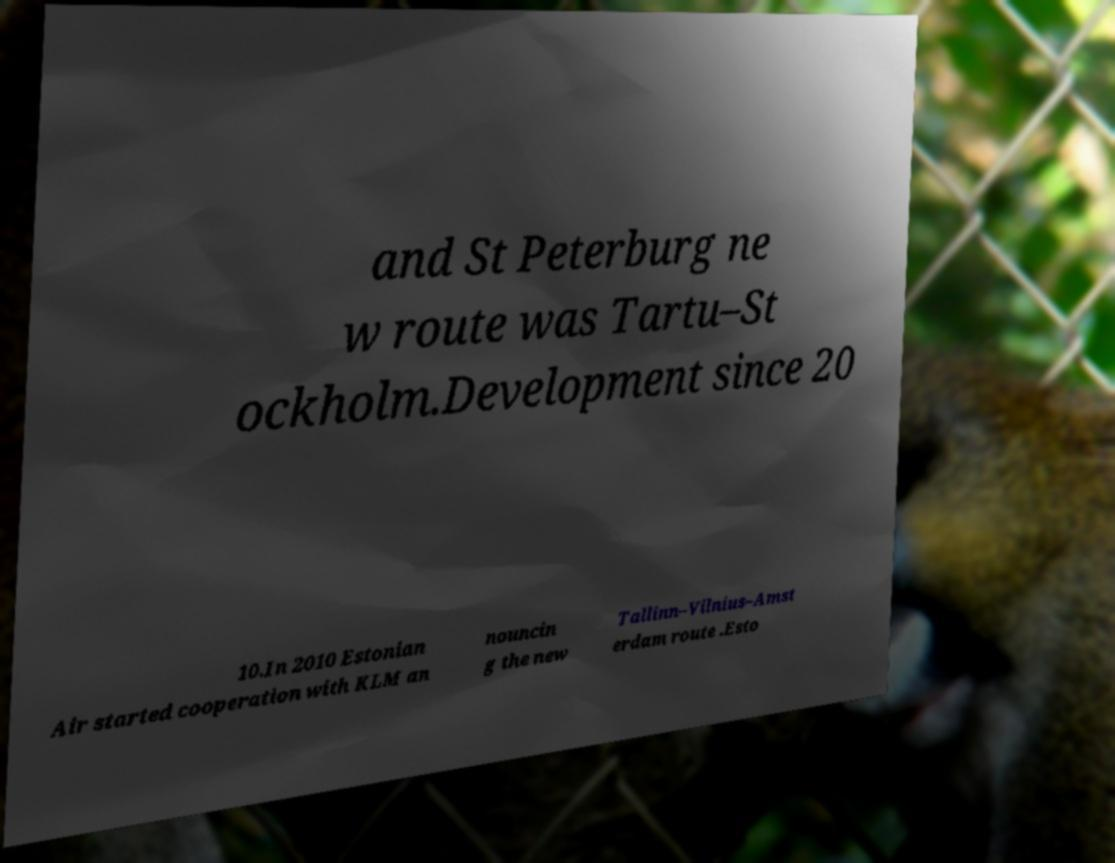Can you read and provide the text displayed in the image?This photo seems to have some interesting text. Can you extract and type it out for me? and St Peterburg ne w route was Tartu–St ockholm.Development since 20 10.In 2010 Estonian Air started cooperation with KLM an nouncin g the new Tallinn–Vilnius–Amst erdam route .Esto 